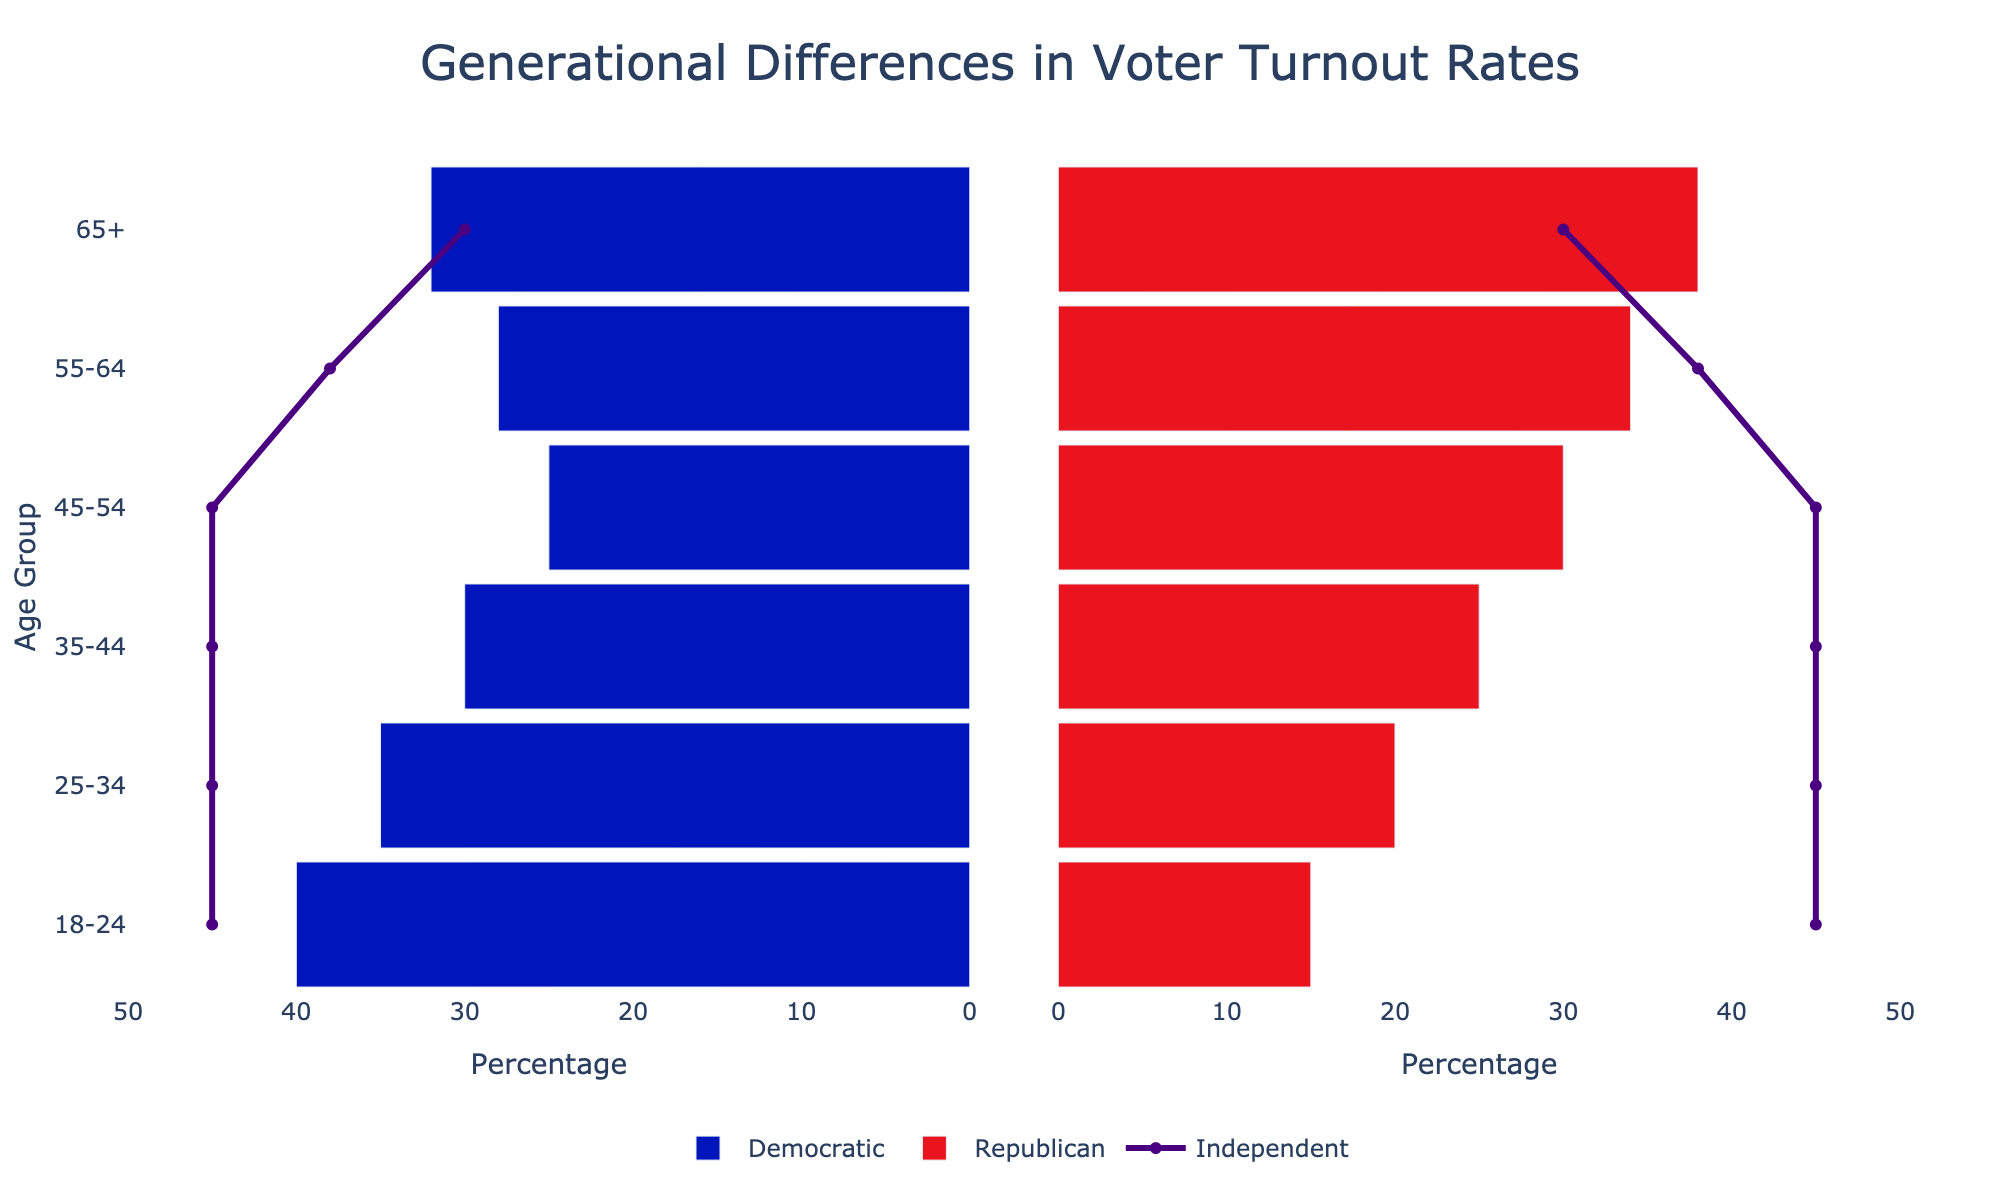What is the title of the figure? The title is located at the top-center of the figure and should be the most noticeable text when first looking at it.
Answer: Generational Differences in Voter Turnout Rates What are the age groups listed on the y-axis? The age groups are displayed vertically along the y-axis on both subplots of the figure. Each bar represents a different age group.
Answer: 65+, 55-64, 45-54, 35-44, 25-34, 18-24 Which political affiliation has the highest voter turnout for the 18-24 age group? Look at the bars and lines representing the 18-24 age group. Compare the lengths of the bars and the position of the line.
Answer: Democratic What age group has the least percentage of Republican voters? Compare the bars representing the Republican affiliation across different age groups and identify the smallest.
Answer: 18-24 What is the percentage of Independent voters in the 25-34 age group? Locate the 25-34 age group and check the corresponding data point on the Independent line.
Answer: 45% Compare the percentages of Democratic and Republican voters in the 35-44 age group. Which is higher and by how much? Find the lengths of the Democratic and Republican bars for the 35-44 age group. Subtract the shorter one from the longer one and note which is higher.
Answer: Democratic is higher by 5% Which age group shows an equal percentage of Independent voters? Examine the position of the Independent line across all age groups to find where it's at the same level.
Answer: All age groups What is the difference in the percentage of Republican voters between the 55-64 and 45-54 age groups? Compare the lengths of the Republican bars between the two age groups and calculate the difference.
Answer: 4% How does the voter turnout for the Independent affiliation change as the age group increases from 18-24 to 65+? Trace the path of the Independent line from the youngest to the oldest age group.
Answer: It remains constant What is the total sum percentage of Democratic and Republican voters in the 65+ age group? Sum the lengths of the Democratic and Republican bars for the 65+ age group.
Answer: 70% 